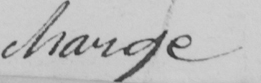Please provide the text content of this handwritten line. charge 